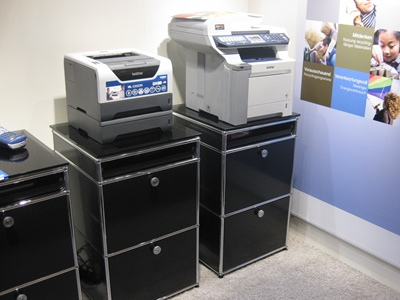<image>
Is the printer on the file cabinet? No. The printer is not positioned on the file cabinet. They may be near each other, but the printer is not supported by or resting on top of the file cabinet. Is there a printer in front of the filing cabinet? No. The printer is not in front of the filing cabinet. The spatial positioning shows a different relationship between these objects. 